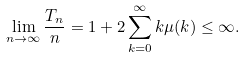<formula> <loc_0><loc_0><loc_500><loc_500>\lim _ { n \to \infty } \frac { T _ { n } } n = 1 + 2 \sum _ { k = 0 } ^ { \infty } k \mu ( k ) \leq \infty .</formula> 